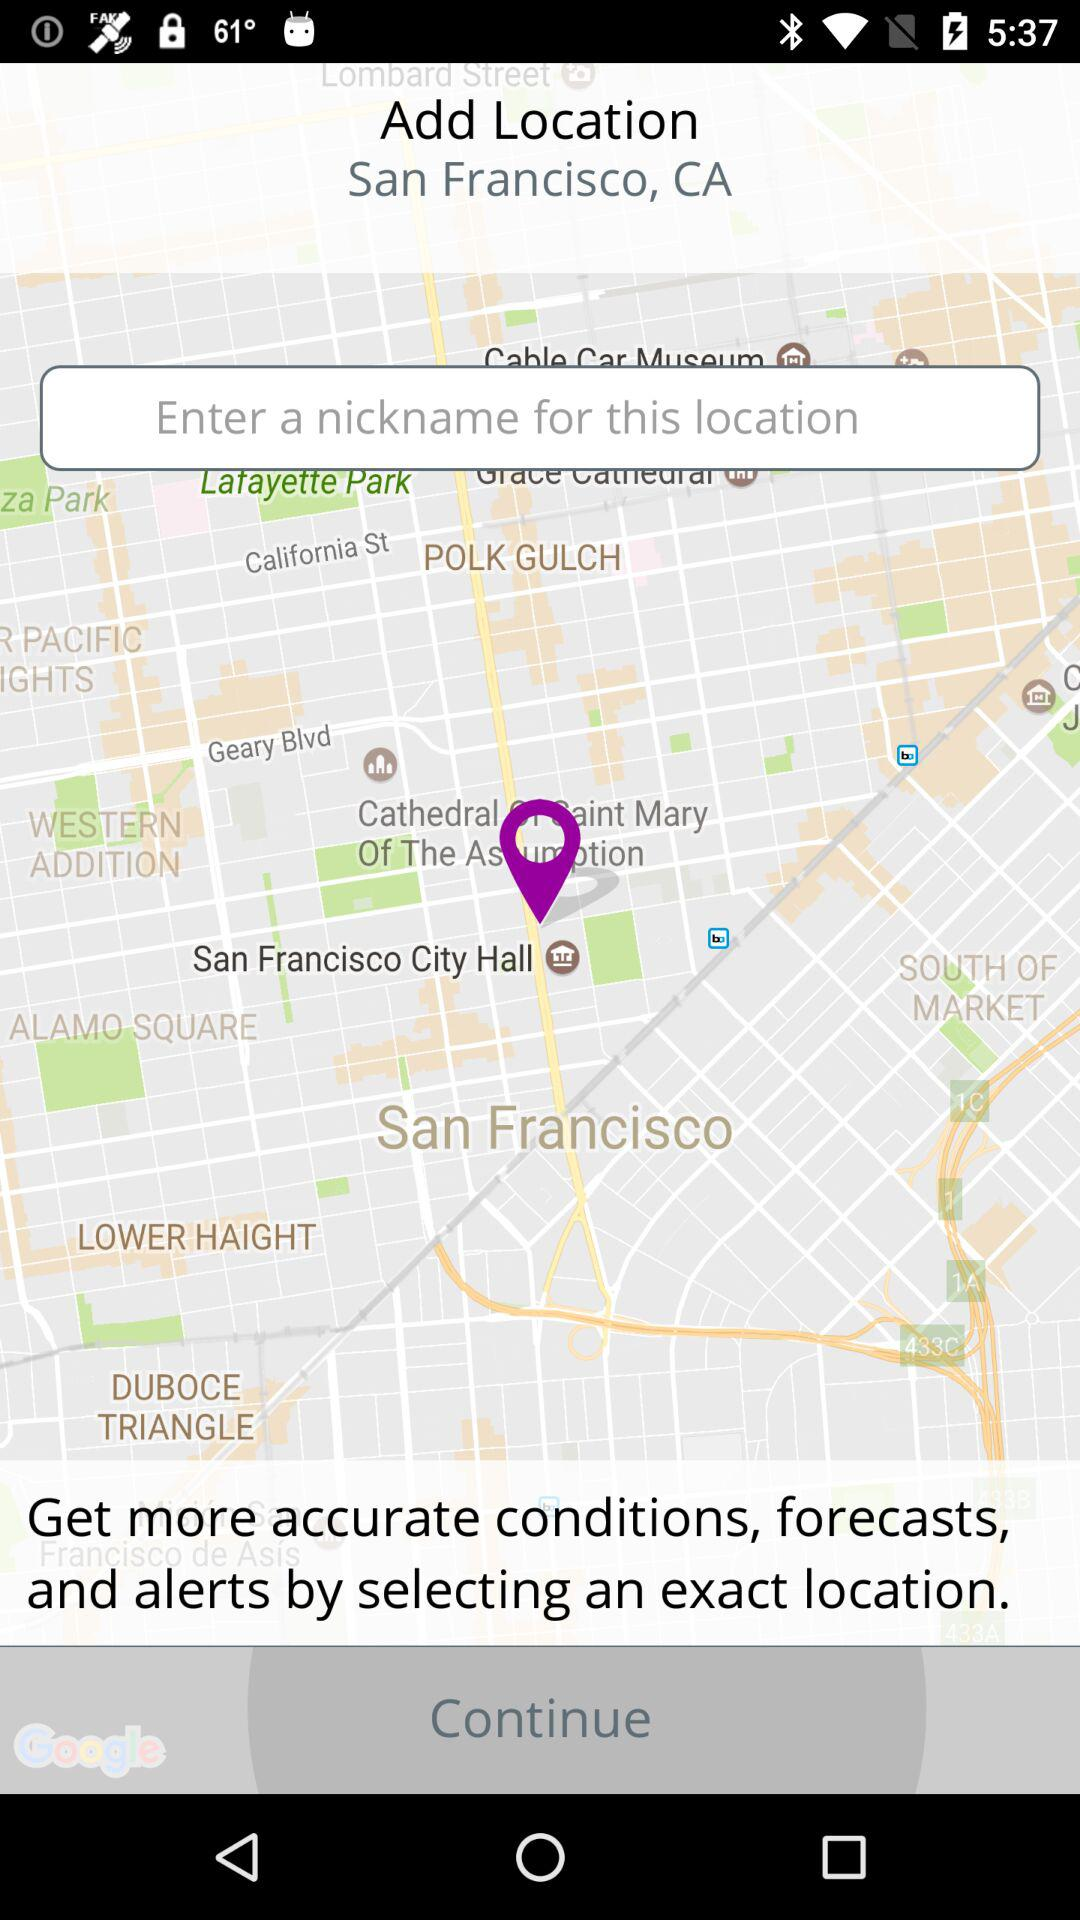How many text inputs are on the screen?
Answer the question using a single word or phrase. 1 